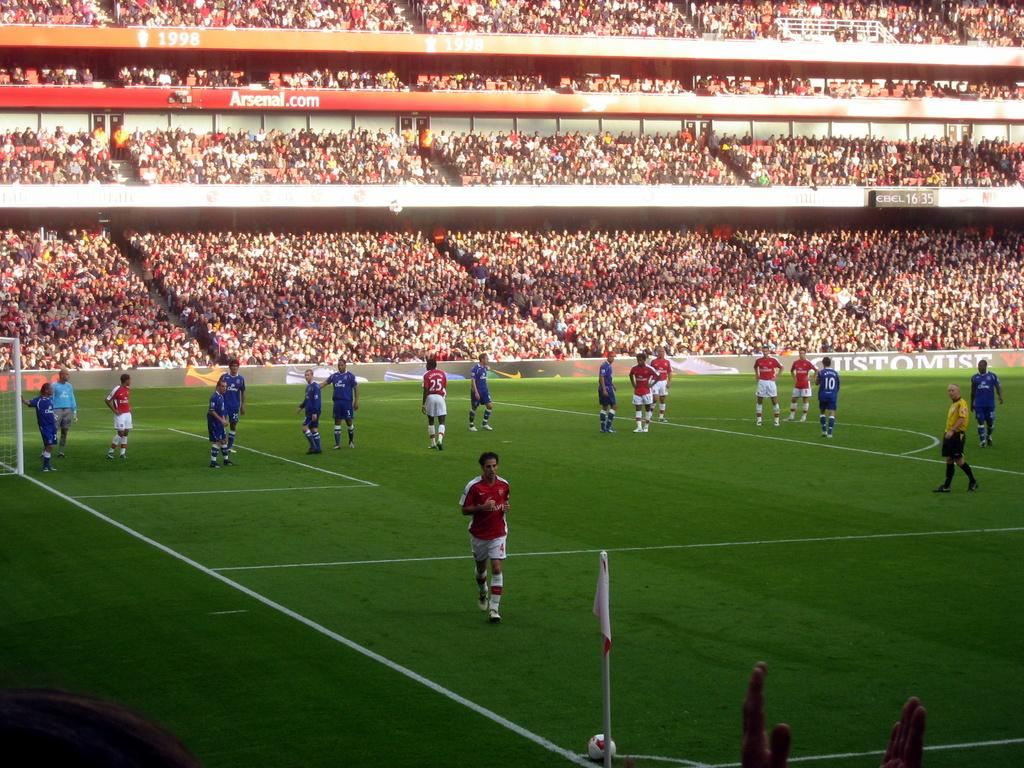Where are the spectators located in the image? The spectators are at the top of the image. What are the persons at the bottom of the image doing? They are standing in the sports ground. What can be seen on a tall structure in the image? There is a flag on a flag post in the image. What might be used to separate the teams or players in the sports ground? There is a sports net in the image. What type of list can be seen in the image? There is no list present in the image. What observation can be made about the spectators in the image? The spectators are located at the top of the image, but there is no specific observation about their behavior or appearance mentioned in the facts. 